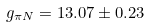<formula> <loc_0><loc_0><loc_500><loc_500>g _ { \pi N } & = 1 3 . 0 7 \pm 0 . 2 3</formula> 